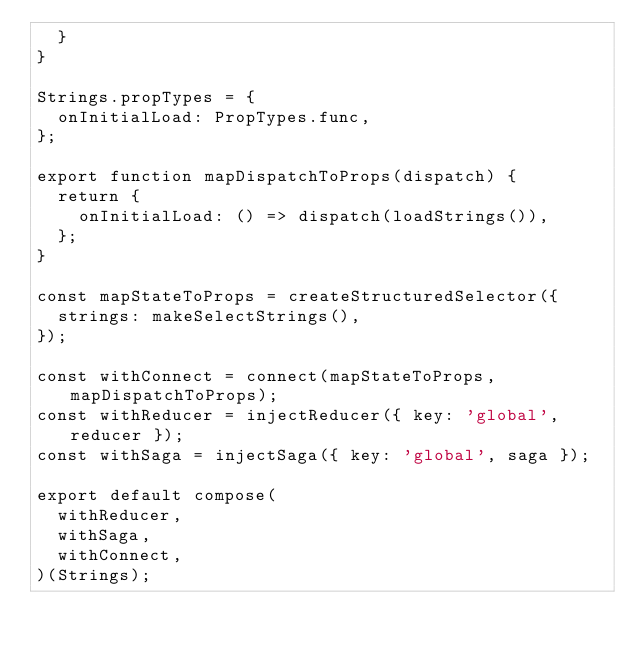Convert code to text. <code><loc_0><loc_0><loc_500><loc_500><_JavaScript_>  }
}

Strings.propTypes = {
  onInitialLoad: PropTypes.func,
};

export function mapDispatchToProps(dispatch) {
  return {
    onInitialLoad: () => dispatch(loadStrings()),
  };
}

const mapStateToProps = createStructuredSelector({
  strings: makeSelectStrings(),
});

const withConnect = connect(mapStateToProps, mapDispatchToProps);
const withReducer = injectReducer({ key: 'global', reducer });
const withSaga = injectSaga({ key: 'global', saga });

export default compose(
  withReducer,
  withSaga,
  withConnect,
)(Strings);
</code> 